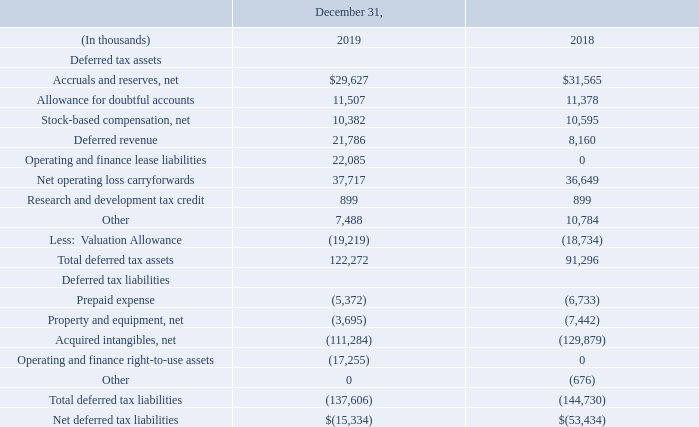Significant components of our deferred tax assets and liabilities consist of the following:
The United States Tax Cuts and Jobs Act (the “Tax Act”) was enacted on December 22, 2017 and introduced significant changes to the income tax law in the United States. Effective in 2018, the Tax Act reduced the United States statutory tax rate from 35% to 21% and created new taxes on certain foreign-sourced earnings and certain related-party payments, which are referred to as the global intangible low-taxed income tax and the base erosion tax, respectively.
In addition, in 2017 we were subject to a one-time transition tax on accumulated foreign subsidiary earnings not previously subject to income tax in the United States.
Due to the timing of the enactment and the complexity involved in applying the provisions of the Tax Act, we made reasonable estimates of the effects and recorded provisional expense of $15.3 million in our financial statements for the year ended December 31, 2017 in accordance with guidance in Staff Accounting Bulletin No. 118 (“SAB 118”), which allows a measurement period of up to one year after the enactment date to finalize the recording of the related tax impacts.
This provisional expense included $10.1 million expense for the remeasurement of deferred tax balances to reflect the lower federal rate and expense of $5.2 million for the one-time transition tax on accumulated foreign subsidiary earnings not previously subject to income tax in the United States.
Adjustments to these provisional amounts that we recorded in 2018 did not have a significant impact on our consolidated financial statements. Our accounting for the effects of the enactment of U.S. Tax Reform is now complete. Due to our divestiture of our investment in Netsmart, the amounts noted above do not include the provisional amounts recorded by Netsmart in 2017.
We had federal net operating loss (“NOL”) carryforwards of $174 million and $164 million as of December 31, 2019, and 2018, respectively. The federal NOL carryforward includes US NOL carryovers of $8 million and Israeli NOL carryovers of $56 million that do not expire. As of December 31, 2019 and 2018, we had state NOL carryforwards of $1 million and $2 million, respectively.
The NOL carryforwards expire in various amounts starting in 2020 for both federal and state tax purposes. The utilization of the federal NOL carryforwards is subject to limitation under the rules regarding changes in stock ownership as determined by the Internal Revenue Code.
When was United States Tax Cuts and Jobs Act (the “Tax Act”) enacted? December 22, 2017. What is the Allowance for doubtful accounts in 2019? 11,507. How much was the federal net operating loss (“NOL”) carryforwards as of December 31, 2019, and 2018 respectively? $174 million, $164 million. What is the change in Accruals and reserves, net between 2019 and 2018?
Answer scale should be: thousand. 29,627-31,565
Answer: -1938. What is the change in Allowance for doubtful accounts between 2019 and 2018?
Answer scale should be: thousand. 11,507-11,378
Answer: 129. What is the change in Stock-based compensation, net between 2019 and 2018?
Answer scale should be: thousand. 10,382-10,595
Answer: -213. 